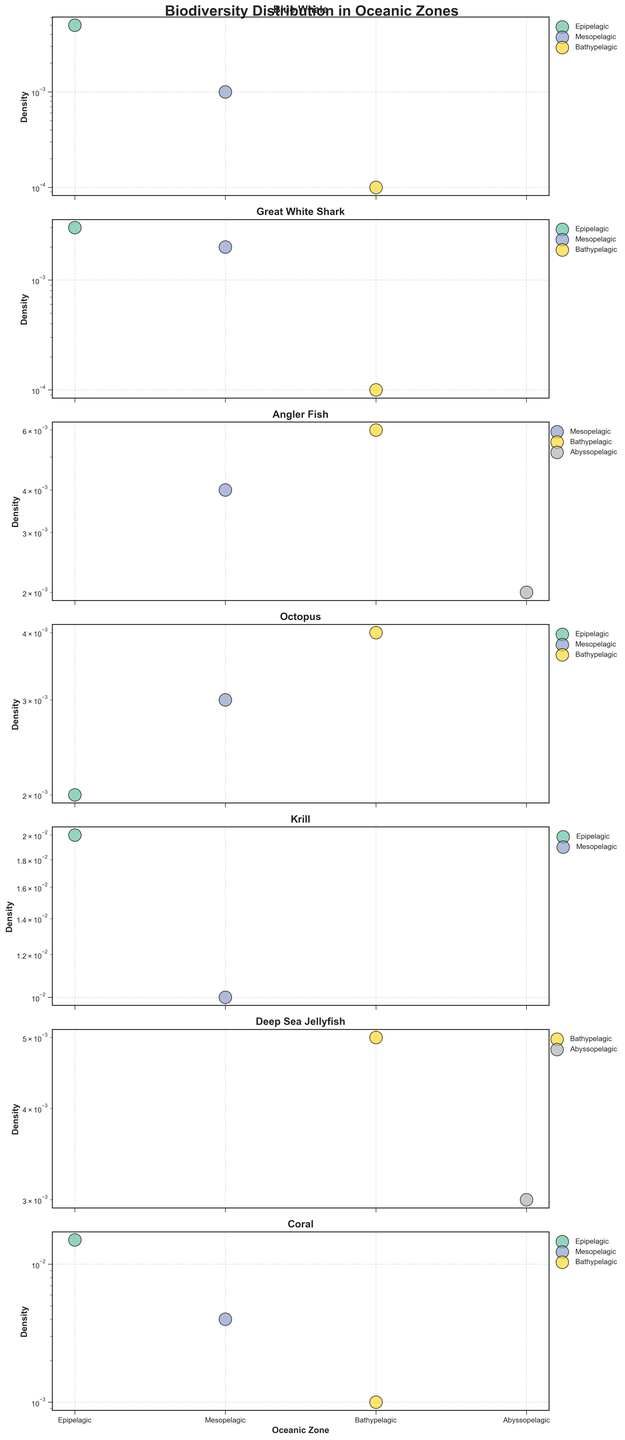What is the title of the figure? The title of the figure is located at the top center of the figure plot. It reads "Biodiversity Distribution in Oceanic Zones".
Answer: Biodiversity Distribution in Oceanic Zones Which species has the highest density in the Epipelagic zone? In the Epipelagic zone, different dots representing species densities are plotted. The species with the highest density is the one positioned highest on the vertical axis for the Epipelagic zone. "Krill" has the highest density at 0.02.
Answer: Krill How many oceanic zones are represented in the figure? Each subplot displays scattered points in various colors, each corresponding to a unique oceanic zone. By counting the distinct colors across all subplots, we find a total of 4 zones: Epipelagic, Mesopelagic, Bathypelagic, and Abyssopelagic.
Answer: 4 In which zone is the density of the Angler Fish the highest? To determine this, observe the individual subplot for the Angler Fish and compare the density values plotted. The Angler Fish has the highest density in the Bathypelagic zone with a density of 0.006.
Answer: Bathypelagic Compare the density of the Great White Shark in the Mesopelagic and Bathypelagic zones. Which one is higher? In the subplot for the Great White Shark, we compare the density points for the Mesopelagic and Bathypelagic zones. The Mesopelagic zone has a density of 0.002, while the Bathypelagic zone has a density of 0.0001. Therefore, Mesopelagic is higher.
Answer: Mesopelagic Which species appear in the Abyssopelagic zone, and what are their densities? By locating the points in the Abyssopelagic zone across all subplots, observe that Angler Fish and Deep Sea Jellyfish appear in this zone. Their densities are 0.002 and 0.003, respectively.
Answer: Angler Fish: 0.002, Deep Sea Jellyfish: 0.003 What is the total density of Coral across all zones? To find the total density, sum the densities of Coral from the Epipelagic, Mesopelagic, and Bathypelagic zones: 0.015 + 0.004 + 0.001 = 0.02.
Answer: 0.02 Which species has the most evenly distributed density across the oceanic zones it is found in? By inspecting the spread of densities in their respective subplots, note that the densities of the Octopus are relatively close across the Epipelagic, Mesopelagic, and Bathypelagic zones: 0.002, 0.003, and 0.004, respectively.
Answer: Octopus 